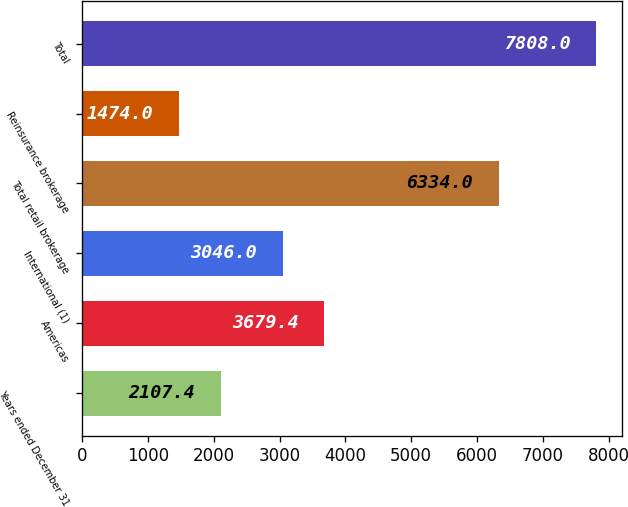<chart> <loc_0><loc_0><loc_500><loc_500><bar_chart><fcel>Years ended December 31<fcel>Americas<fcel>International (1)<fcel>Total retail brokerage<fcel>Reinsurance brokerage<fcel>Total<nl><fcel>2107.4<fcel>3679.4<fcel>3046<fcel>6334<fcel>1474<fcel>7808<nl></chart> 